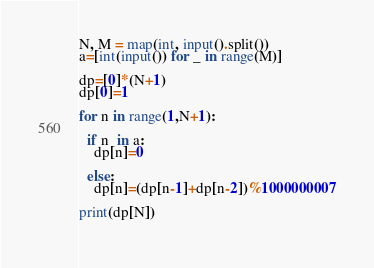Convert code to text. <code><loc_0><loc_0><loc_500><loc_500><_Python_>N, M = map(int, input().split()) 
a=[int(input()) for _ in range(M)]

dp=[0]*(N+1)
dp[0]=1

for n in range(1,N+1):
	
  if n  in a:
    dp[n]=0
    
  else:
    dp[n]=(dp[n-1]+dp[n-2])%1000000007

print(dp[N])
    </code> 